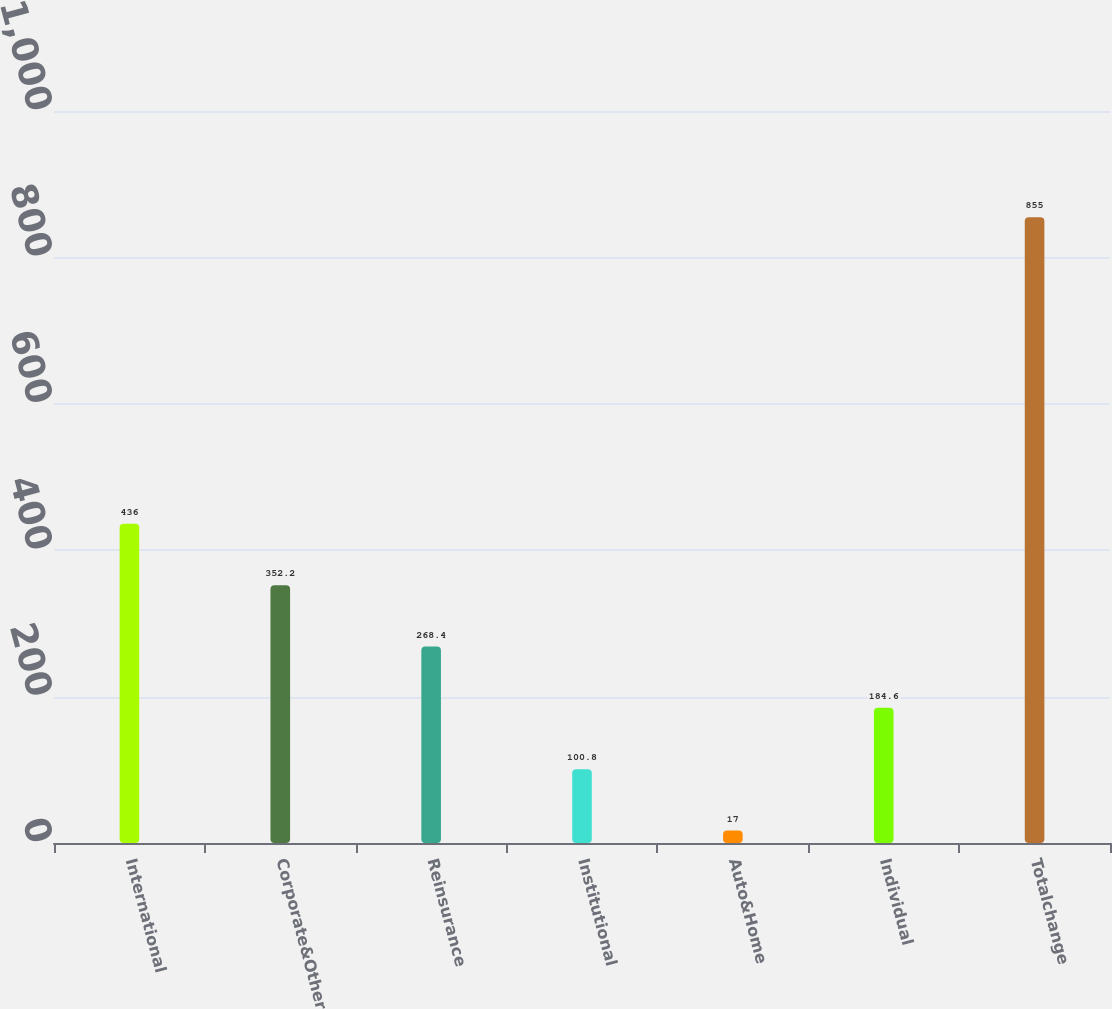Convert chart to OTSL. <chart><loc_0><loc_0><loc_500><loc_500><bar_chart><fcel>International<fcel>Corporate&Other<fcel>Reinsurance<fcel>Institutional<fcel>Auto&Home<fcel>Individual<fcel>Totalchange<nl><fcel>436<fcel>352.2<fcel>268.4<fcel>100.8<fcel>17<fcel>184.6<fcel>855<nl></chart> 